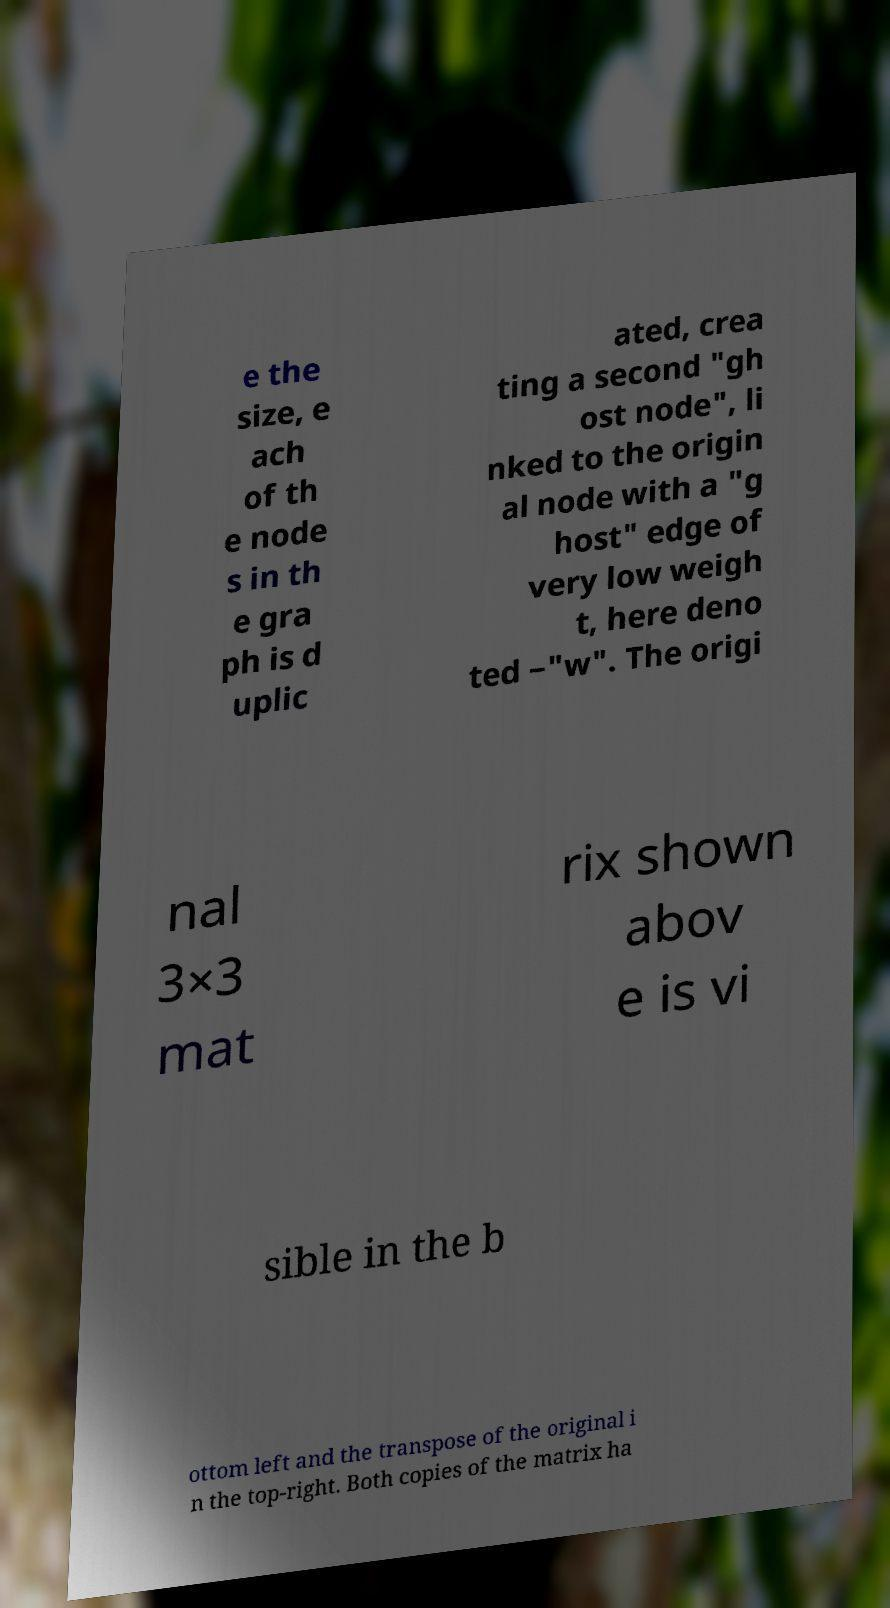Could you assist in decoding the text presented in this image and type it out clearly? e the size, e ach of th e node s in th e gra ph is d uplic ated, crea ting a second "gh ost node", li nked to the origin al node with a "g host" edge of very low weigh t, here deno ted −"w". The origi nal 3×3 mat rix shown abov e is vi sible in the b ottom left and the transpose of the original i n the top-right. Both copies of the matrix ha 